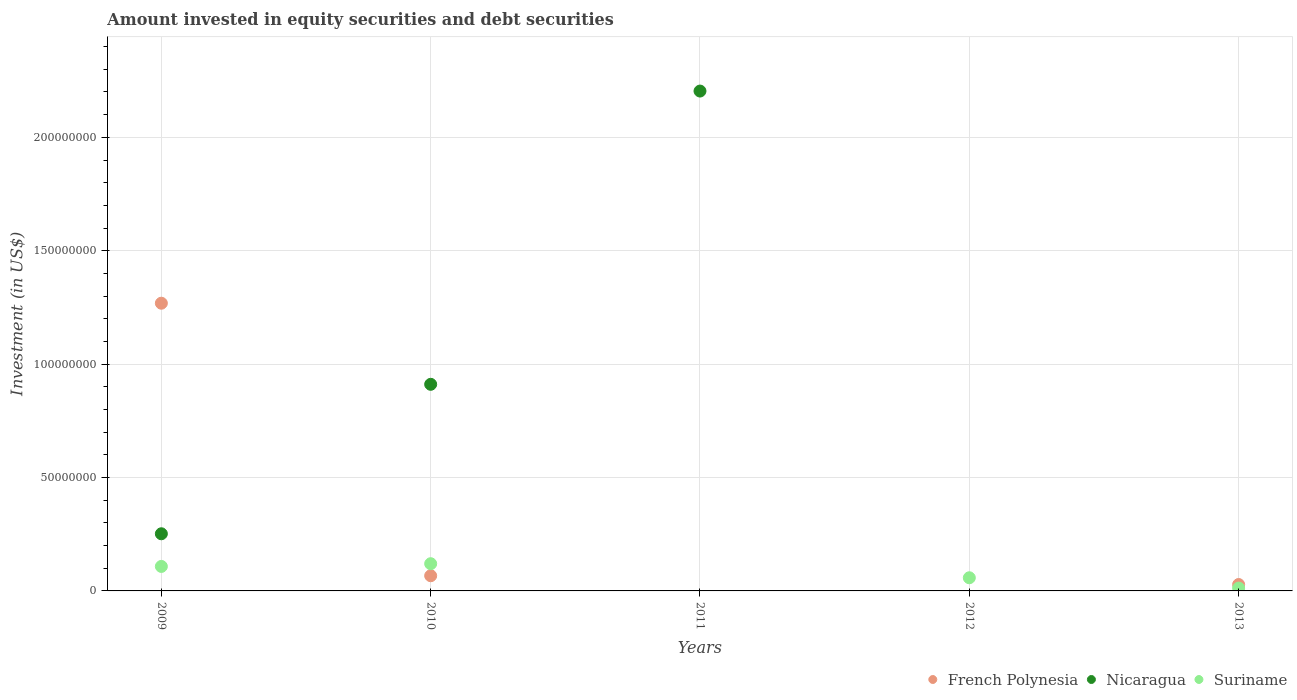How many different coloured dotlines are there?
Make the answer very short. 3. What is the amount invested in equity securities and debt securities in Suriname in 2013?
Give a very brief answer. 1.24e+06. Across all years, what is the maximum amount invested in equity securities and debt securities in Nicaragua?
Provide a succinct answer. 2.20e+08. What is the total amount invested in equity securities and debt securities in Nicaragua in the graph?
Provide a succinct answer. 3.37e+08. What is the difference between the amount invested in equity securities and debt securities in French Polynesia in 2009 and that in 2010?
Give a very brief answer. 1.20e+08. What is the difference between the amount invested in equity securities and debt securities in Nicaragua in 2009 and the amount invested in equity securities and debt securities in French Polynesia in 2010?
Offer a terse response. 1.85e+07. What is the average amount invested in equity securities and debt securities in Nicaragua per year?
Offer a terse response. 6.73e+07. In the year 2013, what is the difference between the amount invested in equity securities and debt securities in Suriname and amount invested in equity securities and debt securities in French Polynesia?
Offer a very short reply. -1.58e+06. In how many years, is the amount invested in equity securities and debt securities in Suriname greater than 30000000 US$?
Your answer should be compact. 0. What is the ratio of the amount invested in equity securities and debt securities in French Polynesia in 2009 to that in 2010?
Provide a succinct answer. 18.95. Is the amount invested in equity securities and debt securities in French Polynesia in 2009 less than that in 2010?
Offer a terse response. No. Is the difference between the amount invested in equity securities and debt securities in Suriname in 2009 and 2013 greater than the difference between the amount invested in equity securities and debt securities in French Polynesia in 2009 and 2013?
Offer a very short reply. No. What is the difference between the highest and the second highest amount invested in equity securities and debt securities in Nicaragua?
Provide a short and direct response. 1.29e+08. What is the difference between the highest and the lowest amount invested in equity securities and debt securities in Nicaragua?
Keep it short and to the point. 2.20e+08. Is the amount invested in equity securities and debt securities in Nicaragua strictly greater than the amount invested in equity securities and debt securities in Suriname over the years?
Provide a succinct answer. No. How many dotlines are there?
Your response must be concise. 3. Does the graph contain grids?
Provide a short and direct response. Yes. Where does the legend appear in the graph?
Your response must be concise. Bottom right. How many legend labels are there?
Make the answer very short. 3. How are the legend labels stacked?
Your answer should be compact. Horizontal. What is the title of the graph?
Your answer should be very brief. Amount invested in equity securities and debt securities. What is the label or title of the Y-axis?
Give a very brief answer. Investment (in US$). What is the Investment (in US$) of French Polynesia in 2009?
Your answer should be very brief. 1.27e+08. What is the Investment (in US$) of Nicaragua in 2009?
Ensure brevity in your answer.  2.52e+07. What is the Investment (in US$) in Suriname in 2009?
Your answer should be compact. 1.08e+07. What is the Investment (in US$) of French Polynesia in 2010?
Ensure brevity in your answer.  6.69e+06. What is the Investment (in US$) in Nicaragua in 2010?
Your answer should be compact. 9.11e+07. What is the Investment (in US$) in Suriname in 2010?
Ensure brevity in your answer.  1.20e+07. What is the Investment (in US$) in French Polynesia in 2011?
Ensure brevity in your answer.  0. What is the Investment (in US$) in Nicaragua in 2011?
Your answer should be very brief. 2.20e+08. What is the Investment (in US$) of Suriname in 2011?
Keep it short and to the point. 0. What is the Investment (in US$) in Nicaragua in 2012?
Your answer should be compact. 0. What is the Investment (in US$) of Suriname in 2012?
Give a very brief answer. 5.80e+06. What is the Investment (in US$) of French Polynesia in 2013?
Provide a short and direct response. 2.82e+06. What is the Investment (in US$) of Suriname in 2013?
Provide a succinct answer. 1.24e+06. Across all years, what is the maximum Investment (in US$) in French Polynesia?
Your answer should be compact. 1.27e+08. Across all years, what is the maximum Investment (in US$) in Nicaragua?
Your response must be concise. 2.20e+08. Across all years, what is the maximum Investment (in US$) in Suriname?
Keep it short and to the point. 1.20e+07. Across all years, what is the minimum Investment (in US$) of Nicaragua?
Provide a succinct answer. 0. What is the total Investment (in US$) of French Polynesia in the graph?
Ensure brevity in your answer.  1.36e+08. What is the total Investment (in US$) of Nicaragua in the graph?
Make the answer very short. 3.37e+08. What is the total Investment (in US$) of Suriname in the graph?
Make the answer very short. 2.98e+07. What is the difference between the Investment (in US$) of French Polynesia in 2009 and that in 2010?
Give a very brief answer. 1.20e+08. What is the difference between the Investment (in US$) in Nicaragua in 2009 and that in 2010?
Provide a succinct answer. -6.59e+07. What is the difference between the Investment (in US$) of Suriname in 2009 and that in 2010?
Offer a very short reply. -1.20e+06. What is the difference between the Investment (in US$) in Nicaragua in 2009 and that in 2011?
Ensure brevity in your answer.  -1.95e+08. What is the difference between the Investment (in US$) of French Polynesia in 2009 and that in 2013?
Provide a short and direct response. 1.24e+08. What is the difference between the Investment (in US$) in Suriname in 2009 and that in 2013?
Offer a terse response. 9.56e+06. What is the difference between the Investment (in US$) in Nicaragua in 2010 and that in 2011?
Give a very brief answer. -1.29e+08. What is the difference between the Investment (in US$) of Suriname in 2010 and that in 2012?
Offer a very short reply. 6.20e+06. What is the difference between the Investment (in US$) in French Polynesia in 2010 and that in 2013?
Keep it short and to the point. 3.87e+06. What is the difference between the Investment (in US$) in Suriname in 2010 and that in 2013?
Give a very brief answer. 1.08e+07. What is the difference between the Investment (in US$) in Suriname in 2012 and that in 2013?
Your response must be concise. 4.56e+06. What is the difference between the Investment (in US$) in French Polynesia in 2009 and the Investment (in US$) in Nicaragua in 2010?
Your answer should be very brief. 3.58e+07. What is the difference between the Investment (in US$) of French Polynesia in 2009 and the Investment (in US$) of Suriname in 2010?
Offer a terse response. 1.15e+08. What is the difference between the Investment (in US$) of Nicaragua in 2009 and the Investment (in US$) of Suriname in 2010?
Provide a short and direct response. 1.32e+07. What is the difference between the Investment (in US$) in French Polynesia in 2009 and the Investment (in US$) in Nicaragua in 2011?
Offer a very short reply. -9.35e+07. What is the difference between the Investment (in US$) of French Polynesia in 2009 and the Investment (in US$) of Suriname in 2012?
Offer a terse response. 1.21e+08. What is the difference between the Investment (in US$) in Nicaragua in 2009 and the Investment (in US$) in Suriname in 2012?
Ensure brevity in your answer.  1.94e+07. What is the difference between the Investment (in US$) in French Polynesia in 2009 and the Investment (in US$) in Suriname in 2013?
Your answer should be compact. 1.26e+08. What is the difference between the Investment (in US$) in Nicaragua in 2009 and the Investment (in US$) in Suriname in 2013?
Keep it short and to the point. 2.40e+07. What is the difference between the Investment (in US$) in French Polynesia in 2010 and the Investment (in US$) in Nicaragua in 2011?
Provide a short and direct response. -2.14e+08. What is the difference between the Investment (in US$) in French Polynesia in 2010 and the Investment (in US$) in Suriname in 2012?
Your answer should be very brief. 8.95e+05. What is the difference between the Investment (in US$) of Nicaragua in 2010 and the Investment (in US$) of Suriname in 2012?
Give a very brief answer. 8.53e+07. What is the difference between the Investment (in US$) of French Polynesia in 2010 and the Investment (in US$) of Suriname in 2013?
Your response must be concise. 5.45e+06. What is the difference between the Investment (in US$) of Nicaragua in 2010 and the Investment (in US$) of Suriname in 2013?
Make the answer very short. 8.99e+07. What is the difference between the Investment (in US$) of Nicaragua in 2011 and the Investment (in US$) of Suriname in 2012?
Your response must be concise. 2.15e+08. What is the difference between the Investment (in US$) in Nicaragua in 2011 and the Investment (in US$) in Suriname in 2013?
Keep it short and to the point. 2.19e+08. What is the average Investment (in US$) in French Polynesia per year?
Provide a short and direct response. 2.73e+07. What is the average Investment (in US$) in Nicaragua per year?
Ensure brevity in your answer.  6.73e+07. What is the average Investment (in US$) of Suriname per year?
Your response must be concise. 5.97e+06. In the year 2009, what is the difference between the Investment (in US$) of French Polynesia and Investment (in US$) of Nicaragua?
Offer a very short reply. 1.02e+08. In the year 2009, what is the difference between the Investment (in US$) of French Polynesia and Investment (in US$) of Suriname?
Your answer should be very brief. 1.16e+08. In the year 2009, what is the difference between the Investment (in US$) in Nicaragua and Investment (in US$) in Suriname?
Give a very brief answer. 1.44e+07. In the year 2010, what is the difference between the Investment (in US$) of French Polynesia and Investment (in US$) of Nicaragua?
Your answer should be very brief. -8.44e+07. In the year 2010, what is the difference between the Investment (in US$) in French Polynesia and Investment (in US$) in Suriname?
Your response must be concise. -5.31e+06. In the year 2010, what is the difference between the Investment (in US$) of Nicaragua and Investment (in US$) of Suriname?
Your answer should be very brief. 7.91e+07. In the year 2013, what is the difference between the Investment (in US$) in French Polynesia and Investment (in US$) in Suriname?
Provide a succinct answer. 1.58e+06. What is the ratio of the Investment (in US$) in French Polynesia in 2009 to that in 2010?
Give a very brief answer. 18.95. What is the ratio of the Investment (in US$) of Nicaragua in 2009 to that in 2010?
Provide a short and direct response. 0.28. What is the ratio of the Investment (in US$) in Suriname in 2009 to that in 2010?
Your response must be concise. 0.9. What is the ratio of the Investment (in US$) of Nicaragua in 2009 to that in 2011?
Provide a short and direct response. 0.11. What is the ratio of the Investment (in US$) of Suriname in 2009 to that in 2012?
Offer a terse response. 1.86. What is the ratio of the Investment (in US$) of French Polynesia in 2009 to that in 2013?
Offer a terse response. 44.95. What is the ratio of the Investment (in US$) in Suriname in 2009 to that in 2013?
Offer a very short reply. 8.69. What is the ratio of the Investment (in US$) of Nicaragua in 2010 to that in 2011?
Provide a short and direct response. 0.41. What is the ratio of the Investment (in US$) of Suriname in 2010 to that in 2012?
Provide a short and direct response. 2.07. What is the ratio of the Investment (in US$) in French Polynesia in 2010 to that in 2013?
Ensure brevity in your answer.  2.37. What is the ratio of the Investment (in US$) of Suriname in 2010 to that in 2013?
Provide a succinct answer. 9.66. What is the ratio of the Investment (in US$) in Suriname in 2012 to that in 2013?
Your answer should be compact. 4.67. What is the difference between the highest and the second highest Investment (in US$) in French Polynesia?
Give a very brief answer. 1.20e+08. What is the difference between the highest and the second highest Investment (in US$) in Nicaragua?
Your answer should be very brief. 1.29e+08. What is the difference between the highest and the second highest Investment (in US$) in Suriname?
Your response must be concise. 1.20e+06. What is the difference between the highest and the lowest Investment (in US$) in French Polynesia?
Offer a very short reply. 1.27e+08. What is the difference between the highest and the lowest Investment (in US$) of Nicaragua?
Your answer should be compact. 2.20e+08. 